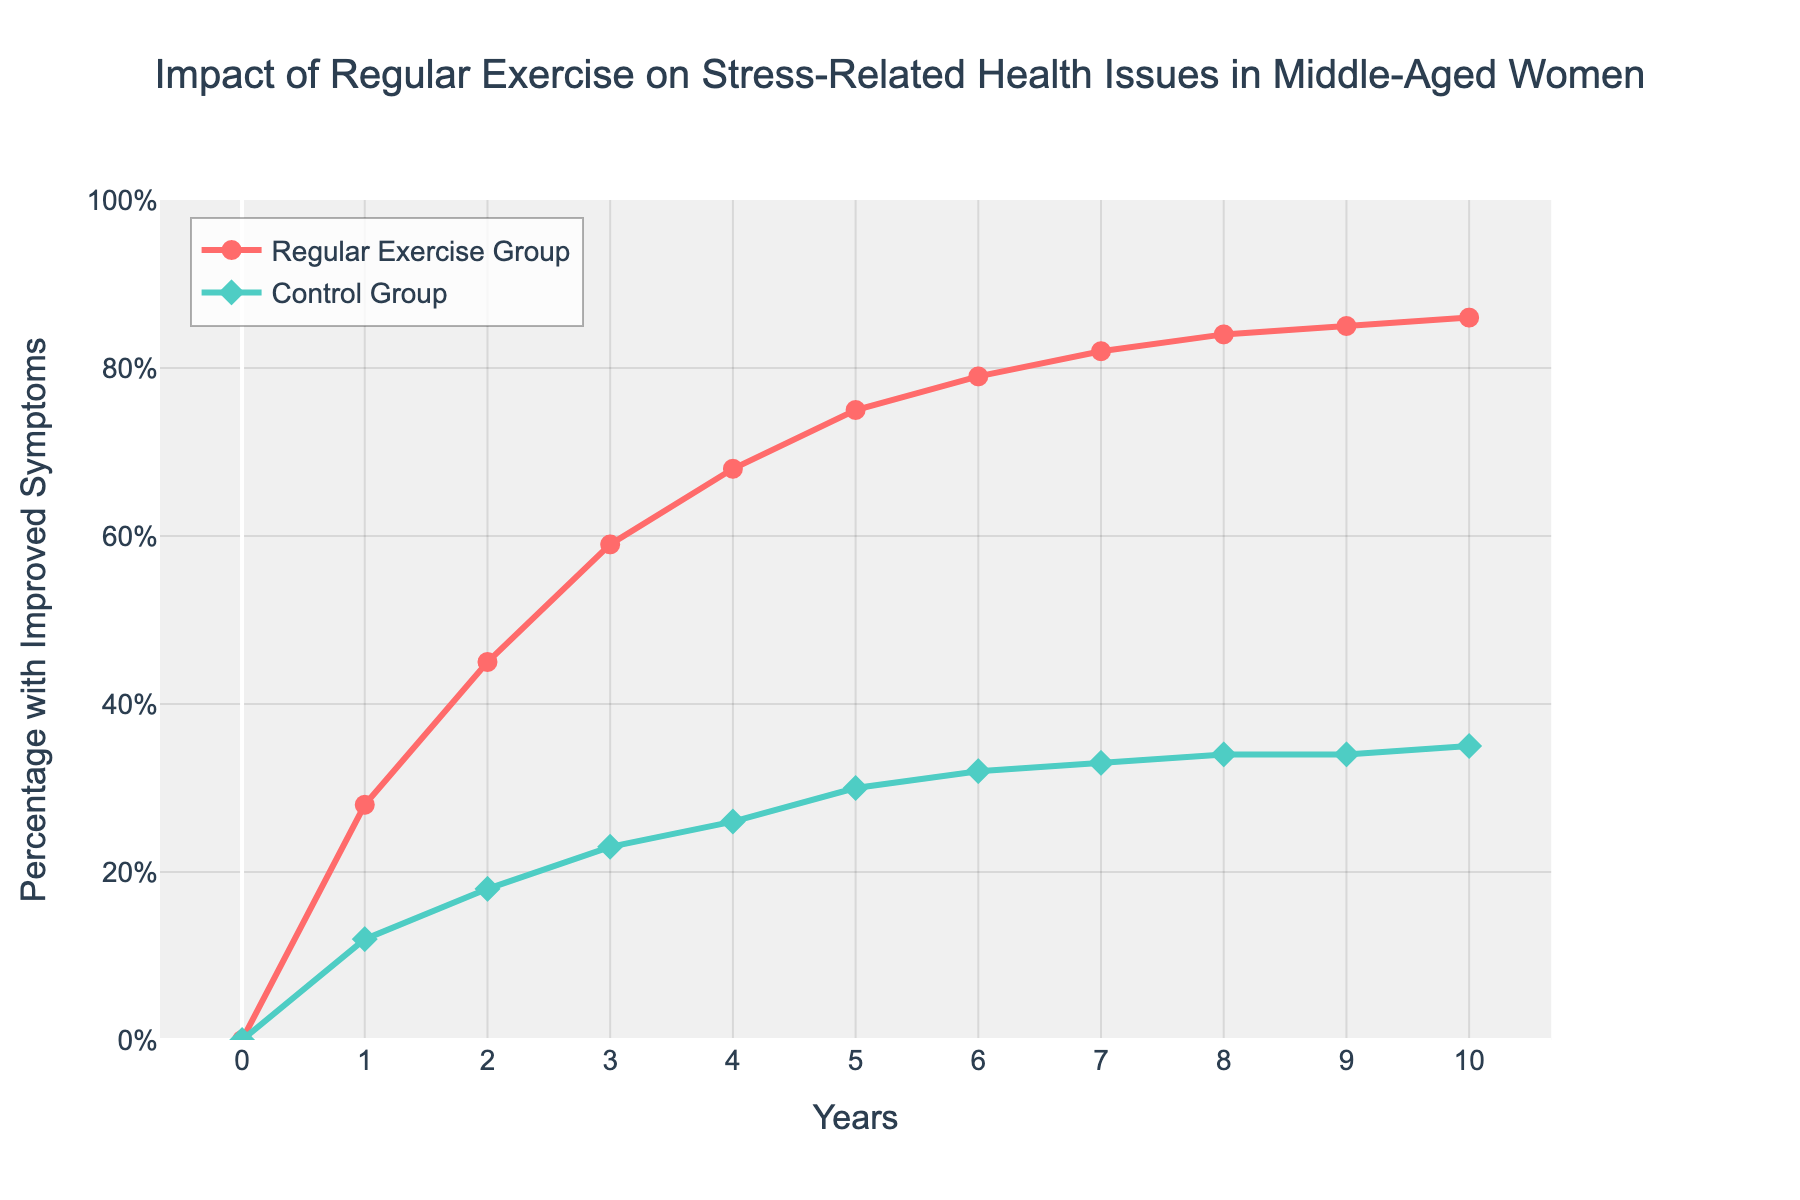What year does the Regular Exercise Group reach around 50% improved symptoms? From the figure, we can see that around the year 2, the Regular Exercise Group crosses the 50% improved symptoms mark.
Answer: Year 2 What is the difference in the percentage of improved symptoms between the Regular Exercise Group and the Control Group at year 5? At year 5, the Regular Exercise Group has 75% improved symptoms and the Control Group has 30%. The difference is 75% - 30% = 45%.
Answer: 45% At which year do the Control Group participants show noticeable improvement for the first time? The Control Group shows noticeable improvement by the year 1 where they achieve 12% improved symptoms.
Answer: Year 1 How much percentage did the Regular Exercise Group improve between year 3 and year 7? At year 3, the percentage was 59% and at year 7, it was 82%. The improvement is 82% - 59% = 23%.
Answer: 23% In which year do both groups have their largest difference in percentage of improved symptoms? By visually identifying differences over the years, the largest difference is observed at year 4 where the Regular Exercise Group has 68% improved symptoms and the Control Group has 26%, resulting in a difference of 68% - 26% = 42%.
Answer: Year 4 Which group shows the higher final improvement in symptoms over the 10-year period? By year 10, the Regular Exercise Group reaches 86% improved symptoms while the Control Group reaches 35%. The Regular Exercise Group has the higher final improvement.
Answer: Regular Exercise Group What is the average percentage of improved symptoms for the Regular Exercise Group from year 1 to year 5? Adding the percentages from year 1 to year 5 for the Regular Exercise Group: (28 + 45 + 59 + 68 + 75) then dividing by 5, we get (275 / 5) which is 55%.
Answer: 55% How does the speed of improvement in the Regular Exercise Group compare to the Control Group in the first two years? In the first two years, the Regular Exercise Group goes from 0% to 45% improved symptoms, which is a 45% increase. The Control Group goes from 0% to 18%, which is an 18% increase. Thus, the Regular Exercise Group shows a much faster improvement.
Answer: Regular Exercise Group faster What is the ratio of improved symptoms in the Regular Exercise Group to the Control Group at year 6? At year 6, the Regular Exercise Group has 79% and the Control Group has 32% improved symptoms. The ratio is 79% / 32% which equals approximately 2.47.
Answer: 2.47 When does the rate of improvement in the Regular Exercise Group start to plateau? From the figure, the improvement rate of the Regular Exercise Group starts to plateau (slow down) around year 7, from 82% onwards.
Answer: Year 7 